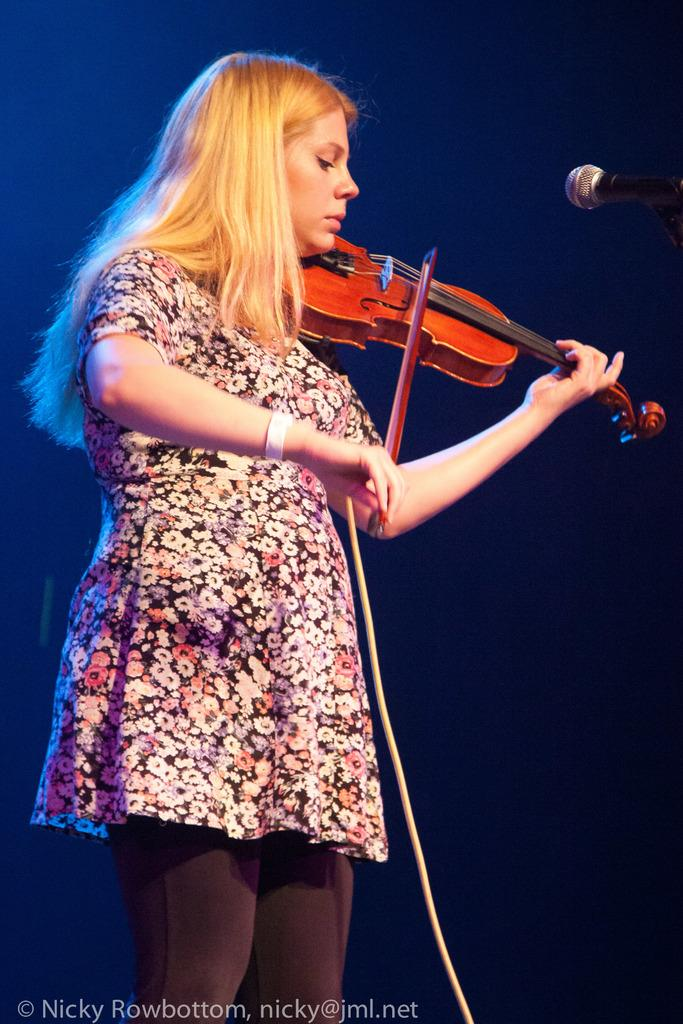Who is the main subject in the image? There is a woman in the image. What is the woman holding in her hand? The woman is holding a violin in her hand. What device is in front of the woman? The woman has a microphone in front of her. Where is the microphone located in the image? The microphone is in the right side top corner of the image. What type of summer activity is the woman participating in the image? The image does not depict a summer activity, nor does it show any indication of the season. 